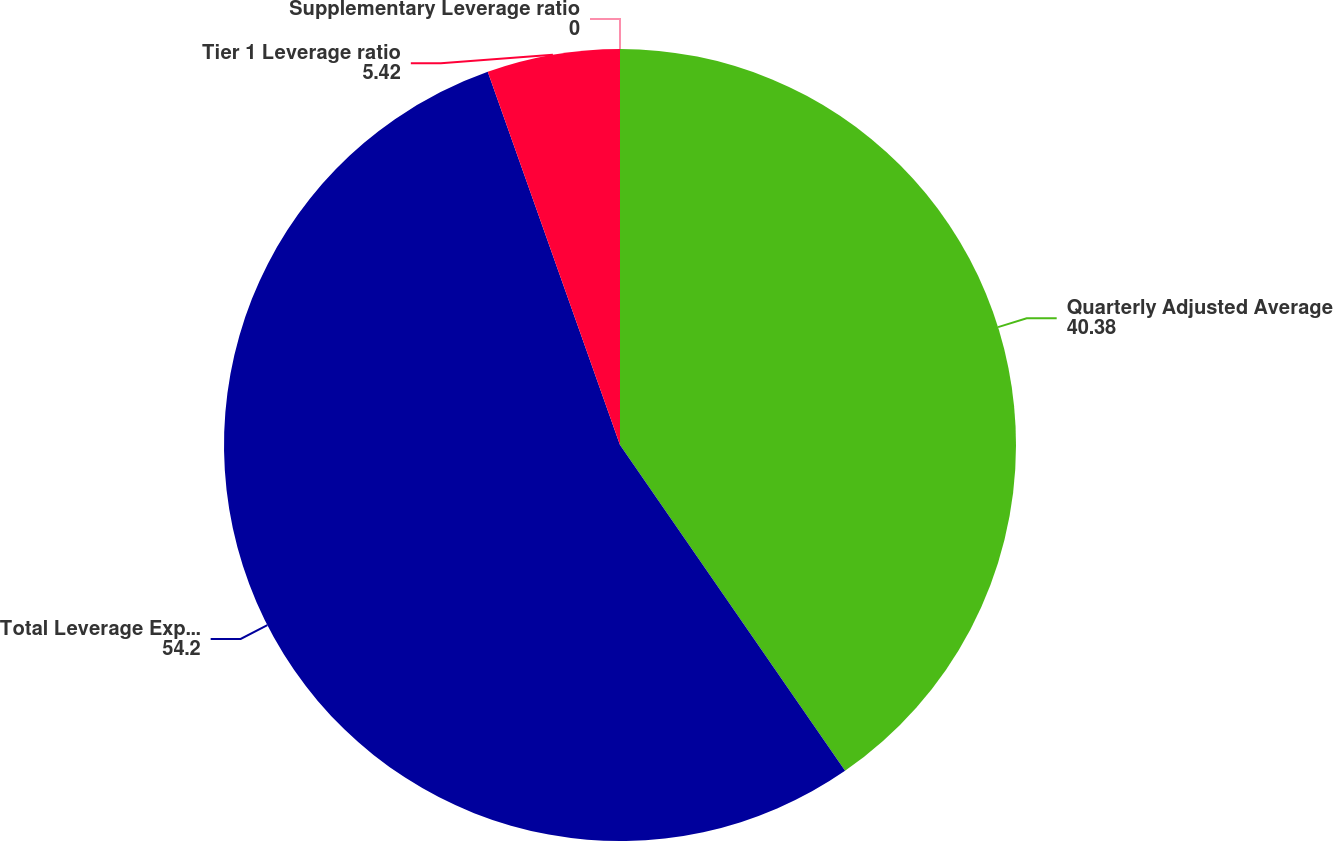Convert chart. <chart><loc_0><loc_0><loc_500><loc_500><pie_chart><fcel>Quarterly Adjusted Average<fcel>Total Leverage Exposure^(6)<fcel>Tier 1 Leverage ratio<fcel>Supplementary Leverage ratio<nl><fcel>40.38%<fcel>54.2%<fcel>5.42%<fcel>0.0%<nl></chart> 